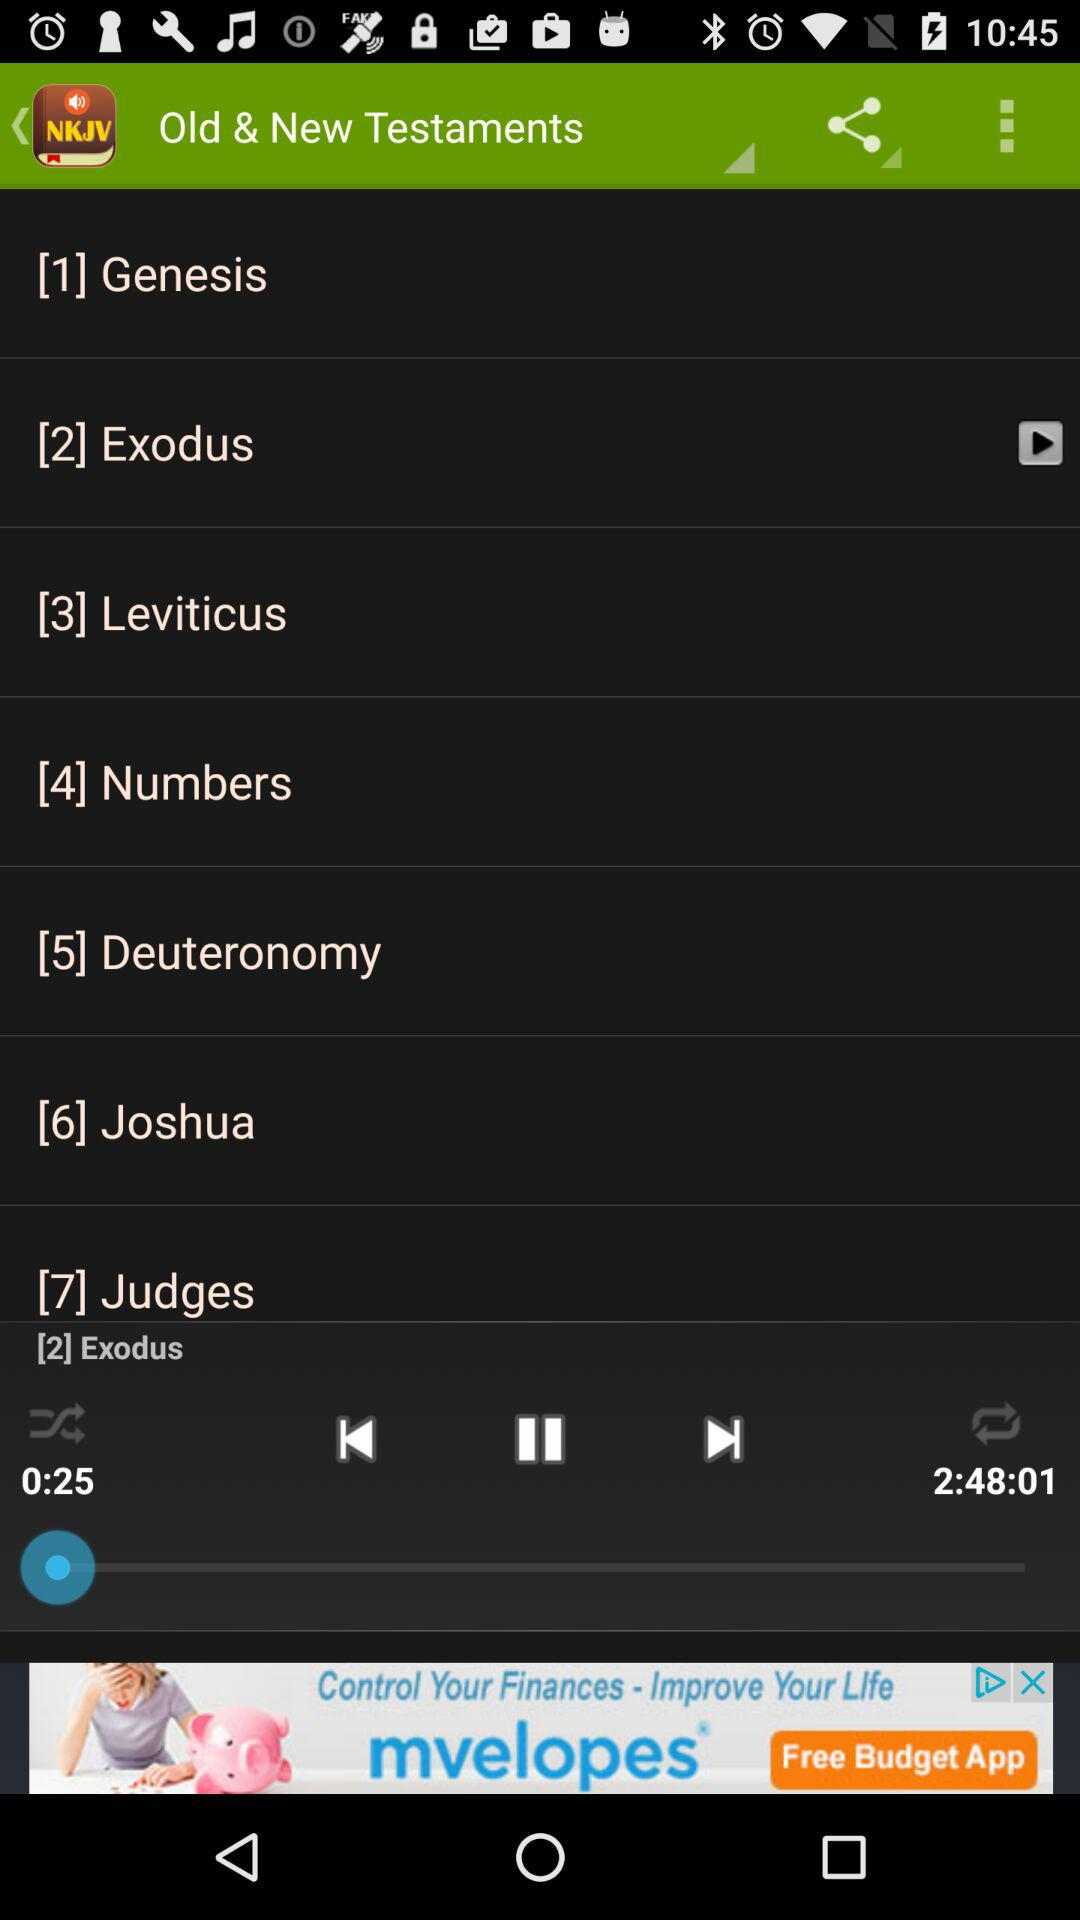What is the duration of the audio that is currently playing? The duration is 2 hours, 48 minutes and 1 second. 